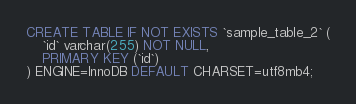Convert code to text. <code><loc_0><loc_0><loc_500><loc_500><_SQL_>CREATE TABLE IF NOT EXISTS `sample_table_2` (
    `id` varchar(255) NOT NULL,
    PRIMARY KEY (`id`)
) ENGINE=InnoDB DEFAULT CHARSET=utf8mb4;</code> 